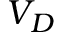Convert formula to latex. <formula><loc_0><loc_0><loc_500><loc_500>V _ { D }</formula> 